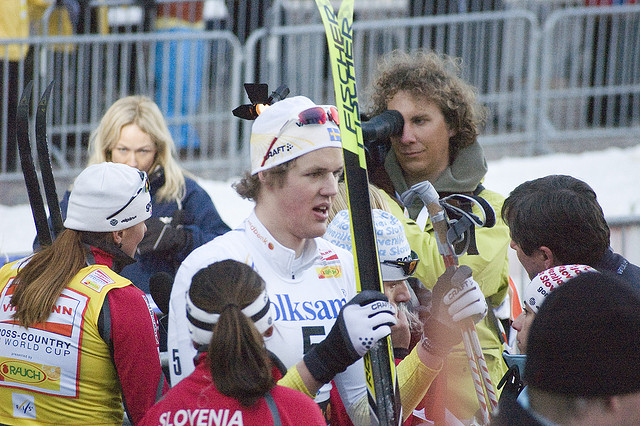Identify the text displayed in this image. RAFT COUNTRY WORLD CUP blksam RAUCH OSS 5 SLOVENIA FISCHER 